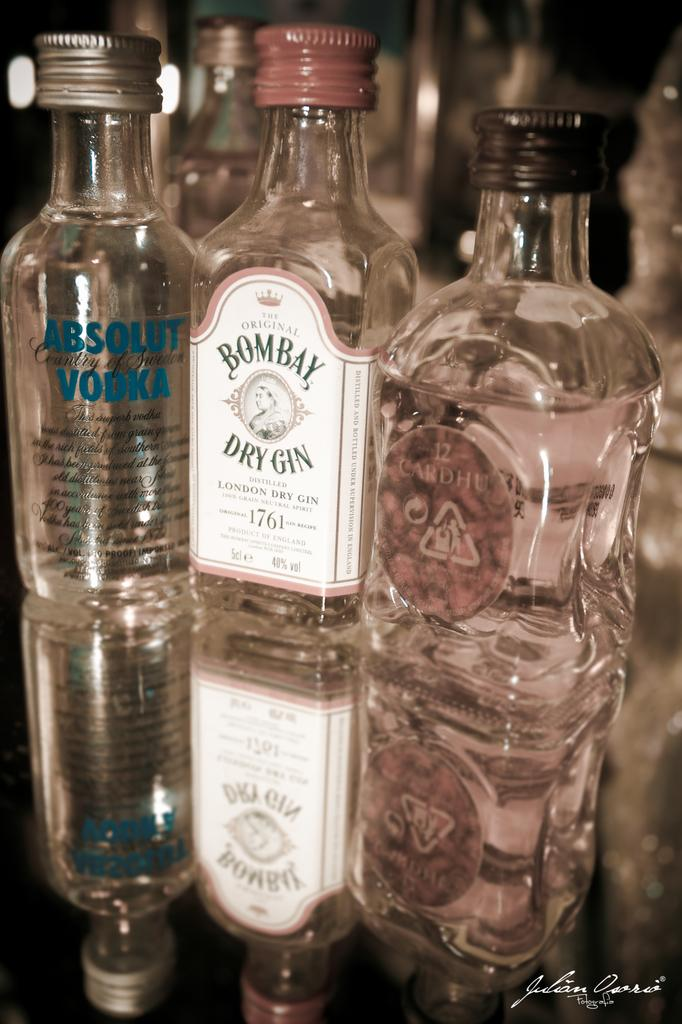<image>
Write a terse but informative summary of the picture. A bottle of Bombay dry gin sits between two other bottles. 